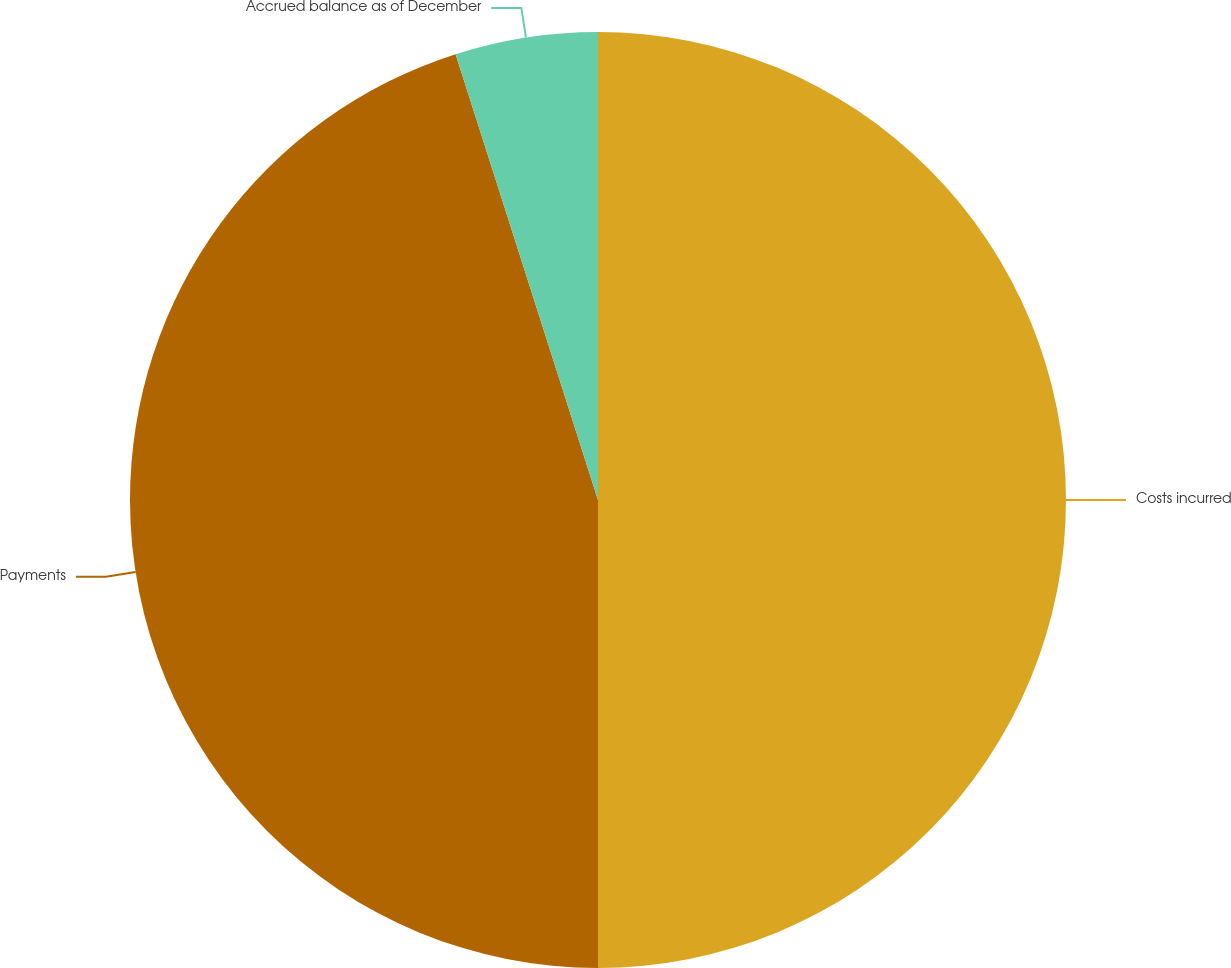Convert chart to OTSL. <chart><loc_0><loc_0><loc_500><loc_500><pie_chart><fcel>Costs incurred<fcel>Payments<fcel>Accrued balance as of December<nl><fcel>50.0%<fcel>45.08%<fcel>4.92%<nl></chart> 